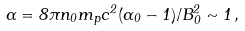Convert formula to latex. <formula><loc_0><loc_0><loc_500><loc_500>\alpha = 8 \pi n _ { 0 } m _ { p } c ^ { 2 } ( \Gamma _ { 0 } - 1 ) / B ^ { 2 } _ { 0 } \sim 1 \, ,</formula> 